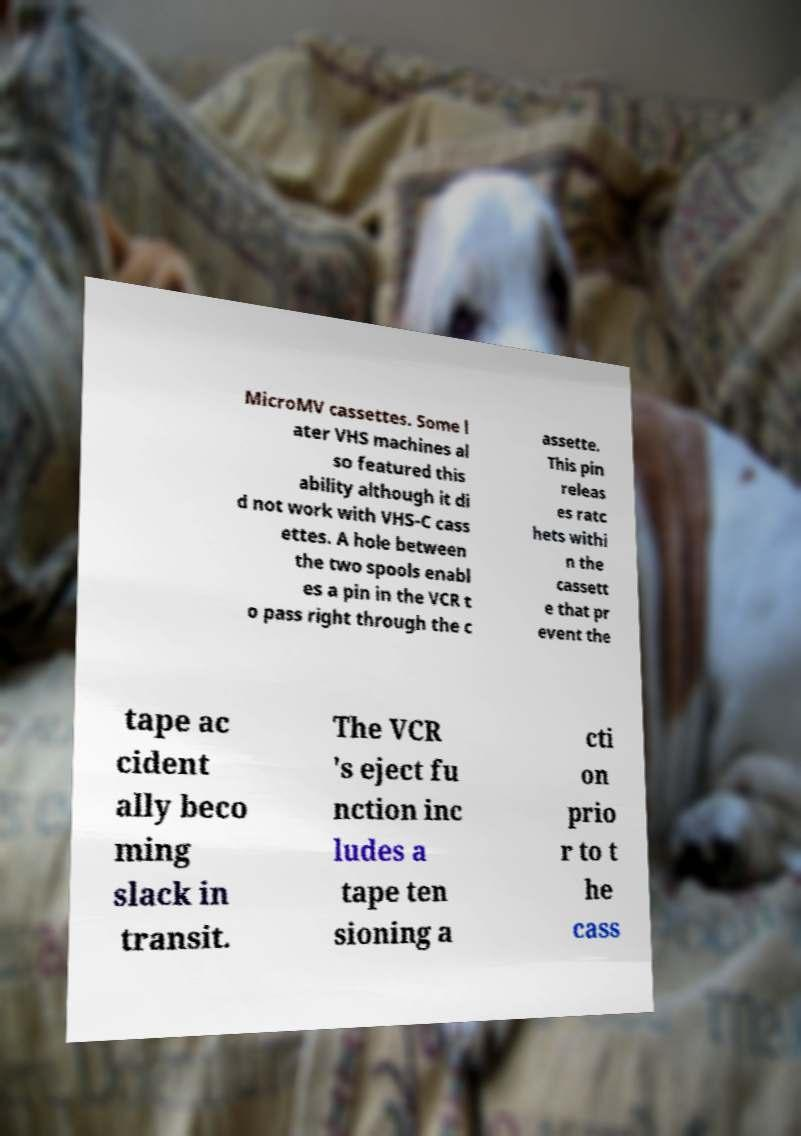There's text embedded in this image that I need extracted. Can you transcribe it verbatim? MicroMV cassettes. Some l ater VHS machines al so featured this ability although it di d not work with VHS-C cass ettes. A hole between the two spools enabl es a pin in the VCR t o pass right through the c assette. This pin releas es ratc hets withi n the cassett e that pr event the tape ac cident ally beco ming slack in transit. The VCR 's eject fu nction inc ludes a tape ten sioning a cti on prio r to t he cass 